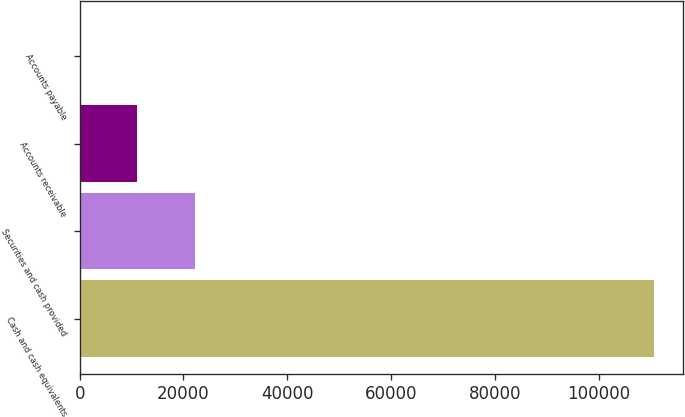<chart> <loc_0><loc_0><loc_500><loc_500><bar_chart><fcel>Cash and cash equivalents<fcel>Securities and cash provided<fcel>Accounts receivable<fcel>Accounts payable<nl><fcel>110642<fcel>22181.2<fcel>11123.6<fcel>66<nl></chart> 